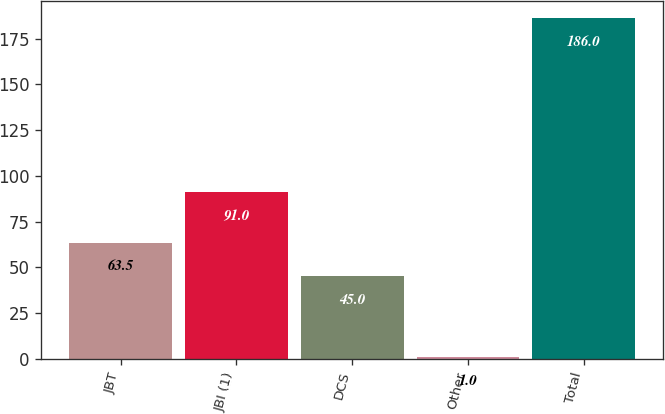Convert chart to OTSL. <chart><loc_0><loc_0><loc_500><loc_500><bar_chart><fcel>JBT<fcel>JBI (1)<fcel>DCS<fcel>Other<fcel>Total<nl><fcel>63.5<fcel>91<fcel>45<fcel>1<fcel>186<nl></chart> 